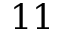Convert formula to latex. <formula><loc_0><loc_0><loc_500><loc_500>1 1</formula> 